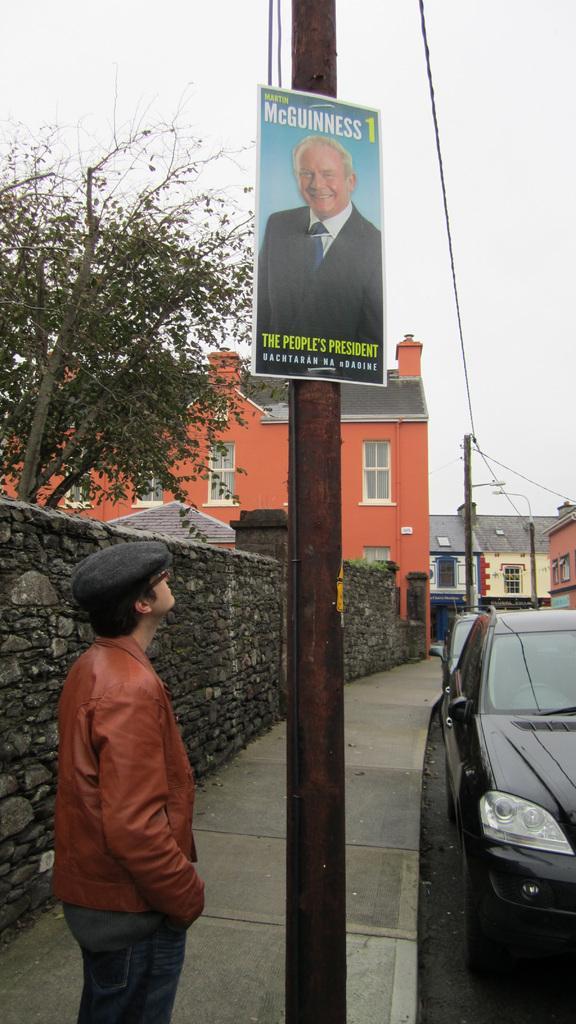How would you summarize this image in a sentence or two? On the right side of this image I can see two cars on the road. Beside the road I can see few poles and a person standing on the footpath and also there is a wall. In the background, I can see few buildings and a tree. On the top of the image I can see the sky. Here I can see a board which is attached to the pole. 